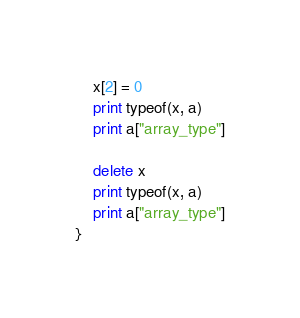Convert code to text. <code><loc_0><loc_0><loc_500><loc_500><_Awk_>	x[2] = 0
	print typeof(x, a)
	print a["array_type"]

	delete x
	print typeof(x, a)
	print a["array_type"]
}
</code> 